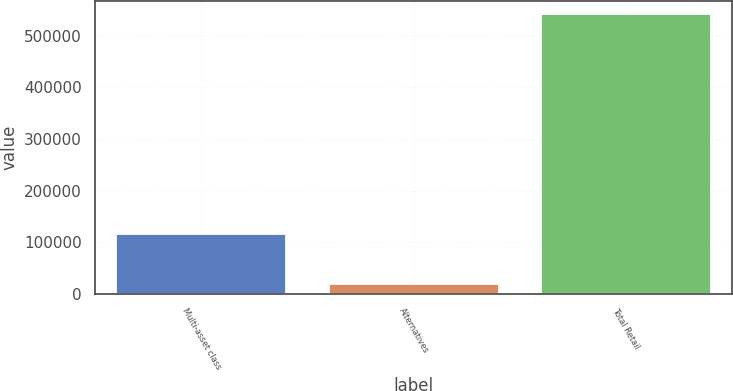Convert chart. <chart><loc_0><loc_0><loc_500><loc_500><bar_chart><fcel>Multi-asset class<fcel>Alternatives<fcel>Total Retail<nl><fcel>115307<fcel>19410<fcel>541125<nl></chart> 